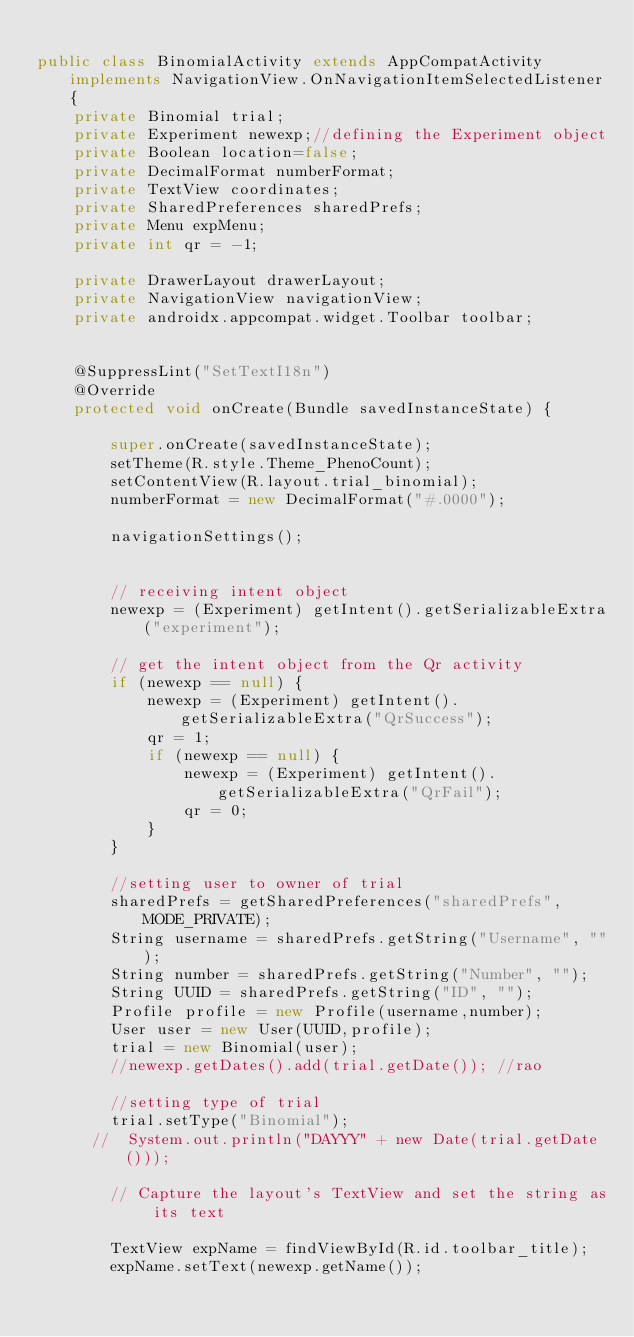<code> <loc_0><loc_0><loc_500><loc_500><_Java_>
public class BinomialActivity extends AppCompatActivity implements NavigationView.OnNavigationItemSelectedListener{
    private Binomial trial;
    private Experiment newexp;//defining the Experiment object
    private Boolean location=false;
    private DecimalFormat numberFormat;
    private TextView coordinates;
    private SharedPreferences sharedPrefs;
    private Menu expMenu;
    private int qr = -1;

    private DrawerLayout drawerLayout;
    private NavigationView navigationView;
    private androidx.appcompat.widget.Toolbar toolbar;


    @SuppressLint("SetTextI18n")
    @Override
    protected void onCreate(Bundle savedInstanceState) {

        super.onCreate(savedInstanceState);
        setTheme(R.style.Theme_PhenoCount);
        setContentView(R.layout.trial_binomial);
        numberFormat = new DecimalFormat("#.0000");

        navigationSettings();


        // receiving intent object
        newexp = (Experiment) getIntent().getSerializableExtra("experiment");

        // get the intent object from the Qr activity
        if (newexp == null) {
            newexp = (Experiment) getIntent().getSerializableExtra("QrSuccess");
            qr = 1;
            if (newexp == null) {
                newexp = (Experiment) getIntent().getSerializableExtra("QrFail");
                qr = 0;
            }
        }

        //setting user to owner of trial
        sharedPrefs = getSharedPreferences("sharedPrefs", MODE_PRIVATE);
        String username = sharedPrefs.getString("Username", "");
        String number = sharedPrefs.getString("Number", "");
        String UUID = sharedPrefs.getString("ID", "");
        Profile profile = new Profile(username,number);
        User user = new User(UUID,profile);
        trial = new Binomial(user);
        //newexp.getDates().add(trial.getDate()); //rao

        //setting type of trial
        trial.setType("Binomial");
      //  System.out.println("DAYYY" + new Date(trial.getDate()));

        // Capture the layout's TextView and set the string as its text

        TextView expName = findViewById(R.id.toolbar_title);
        expName.setText(newexp.getName());
</code> 